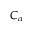Convert formula to latex. <formula><loc_0><loc_0><loc_500><loc_500>C _ { \alpha }</formula> 